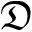<formula> <loc_0><loc_0><loc_500><loc_500>\mathfrak { D }</formula> 